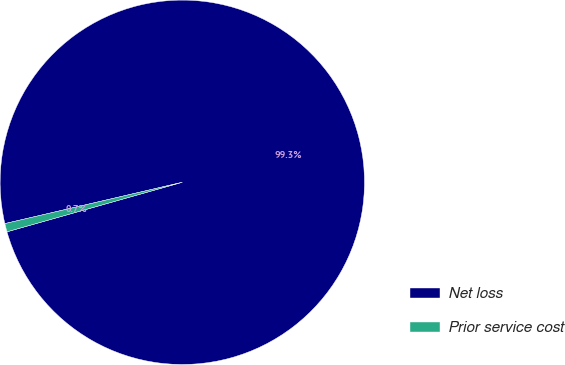<chart> <loc_0><loc_0><loc_500><loc_500><pie_chart><fcel>Net loss<fcel>Prior service cost<nl><fcel>99.26%<fcel>0.74%<nl></chart> 